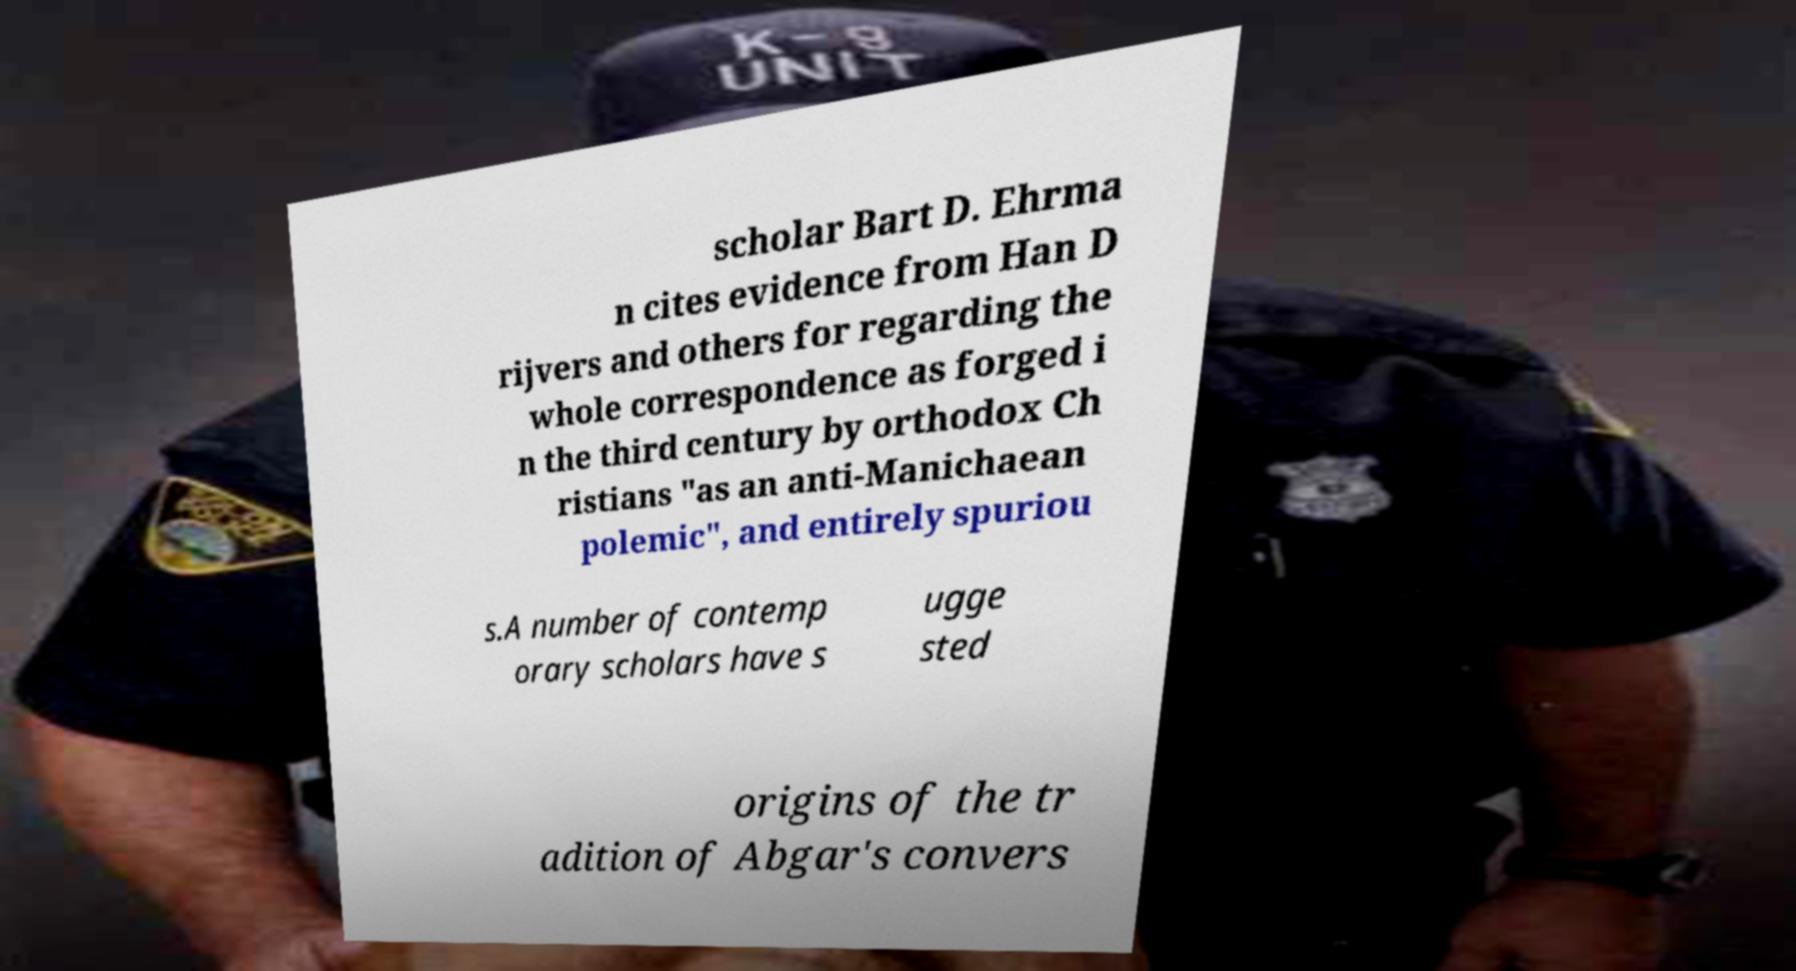Please read and relay the text visible in this image. What does it say? scholar Bart D. Ehrma n cites evidence from Han D rijvers and others for regarding the whole correspondence as forged i n the third century by orthodox Ch ristians "as an anti-Manichaean polemic", and entirely spuriou s.A number of contemp orary scholars have s ugge sted origins of the tr adition of Abgar's convers 